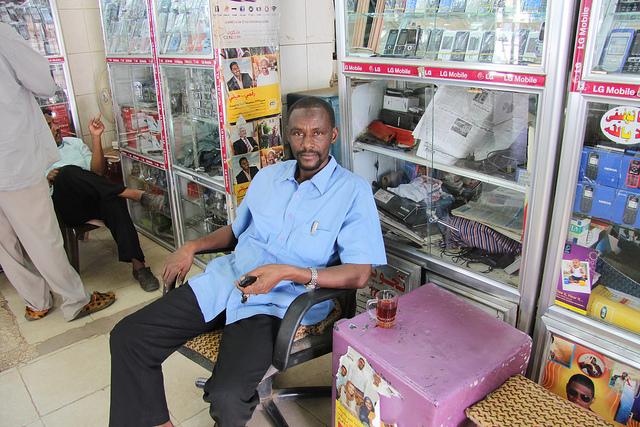What color is the man's shirt?
Answer briefly. Blue. Is the man standing?
Concise answer only. No. Does the man have something in his hand?
Short answer required. Yes. 